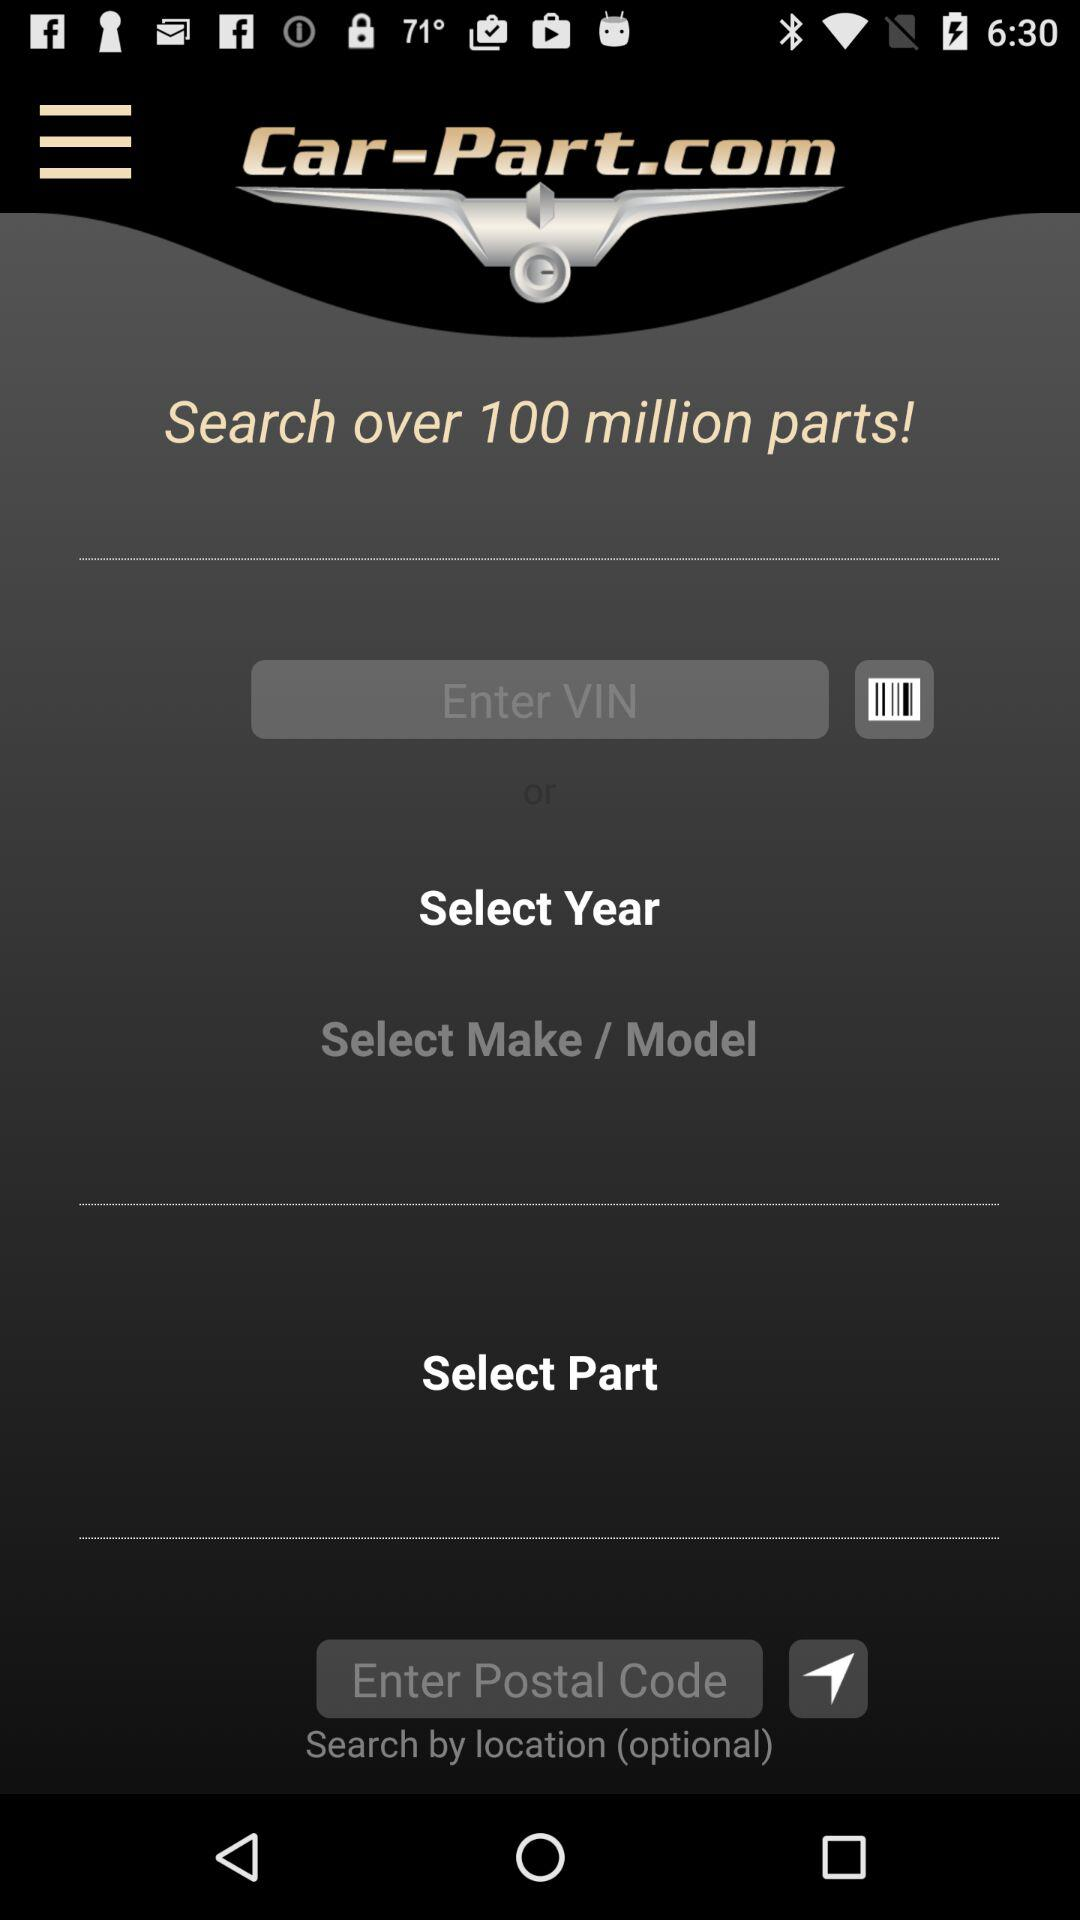What is the application name? The application name is "Car-Part.com". 